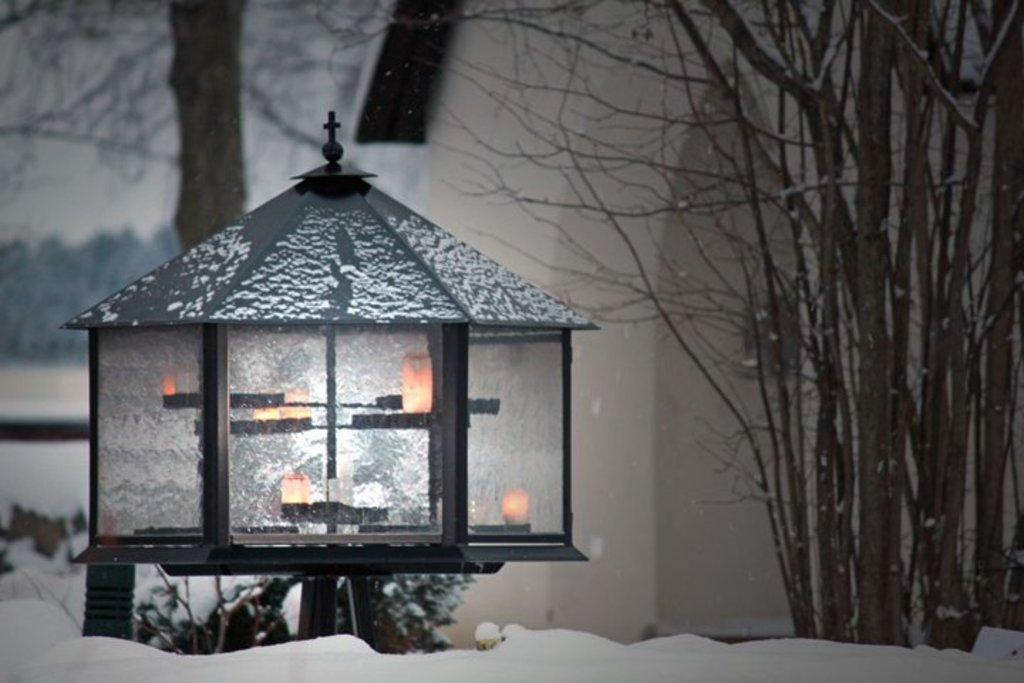What object is the main focus of the image? There is a lantern in the image. What can be seen in the background of the image? There are trees and a house in the background of the image. What type of weather is suggested by the presence of snow in the image? The presence of snow suggests that the image is set in a cold environment, possibly during winter. Can you see any fish swimming in the snow in the image? There are no fish present in the image, and the snow is not a body of water where fish could swim. 